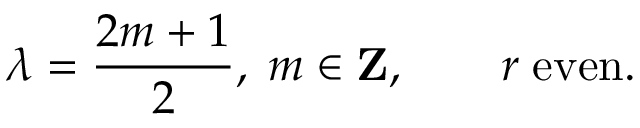Convert formula to latex. <formula><loc_0><loc_0><loc_500><loc_500>\lambda = { \frac { 2 m + 1 } { 2 } } , \, m \in { Z } , \quad r \, e v e n .</formula> 